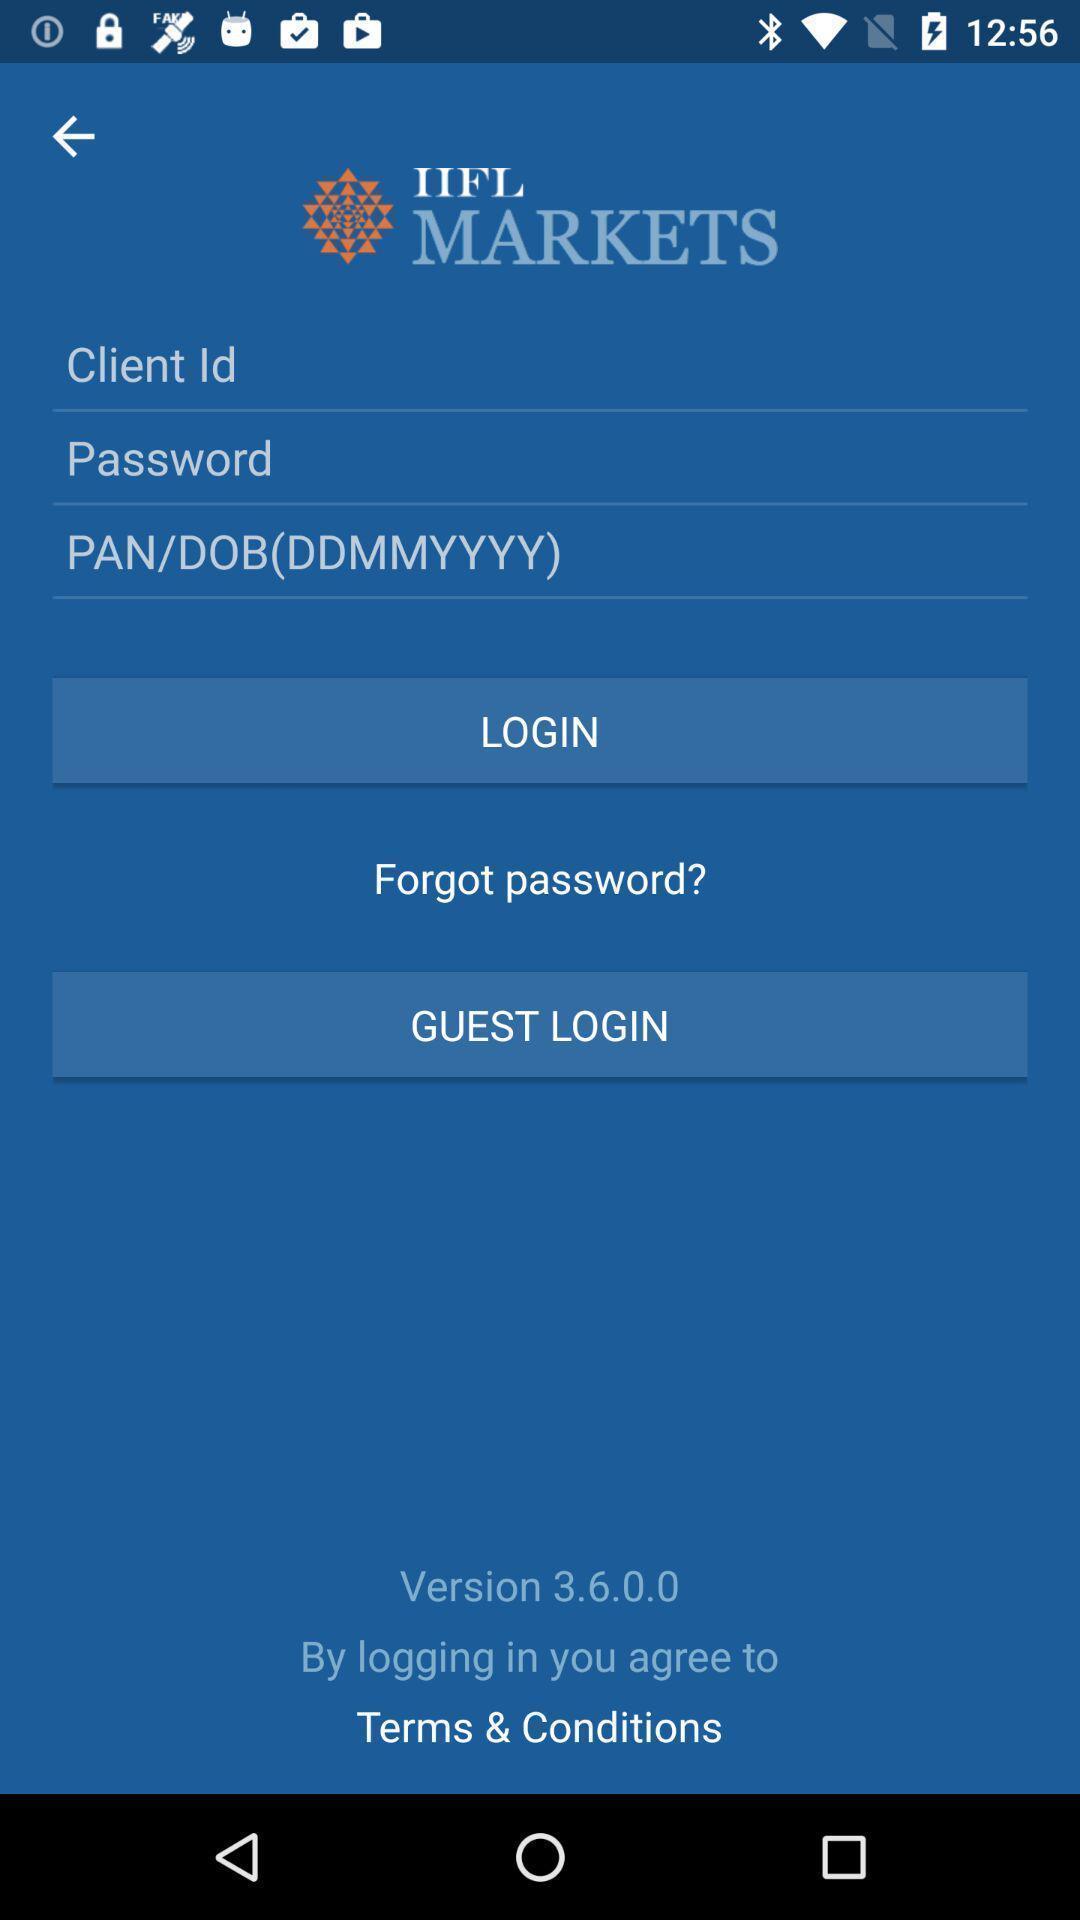What is the overall content of this screenshot? Page showing login page. 